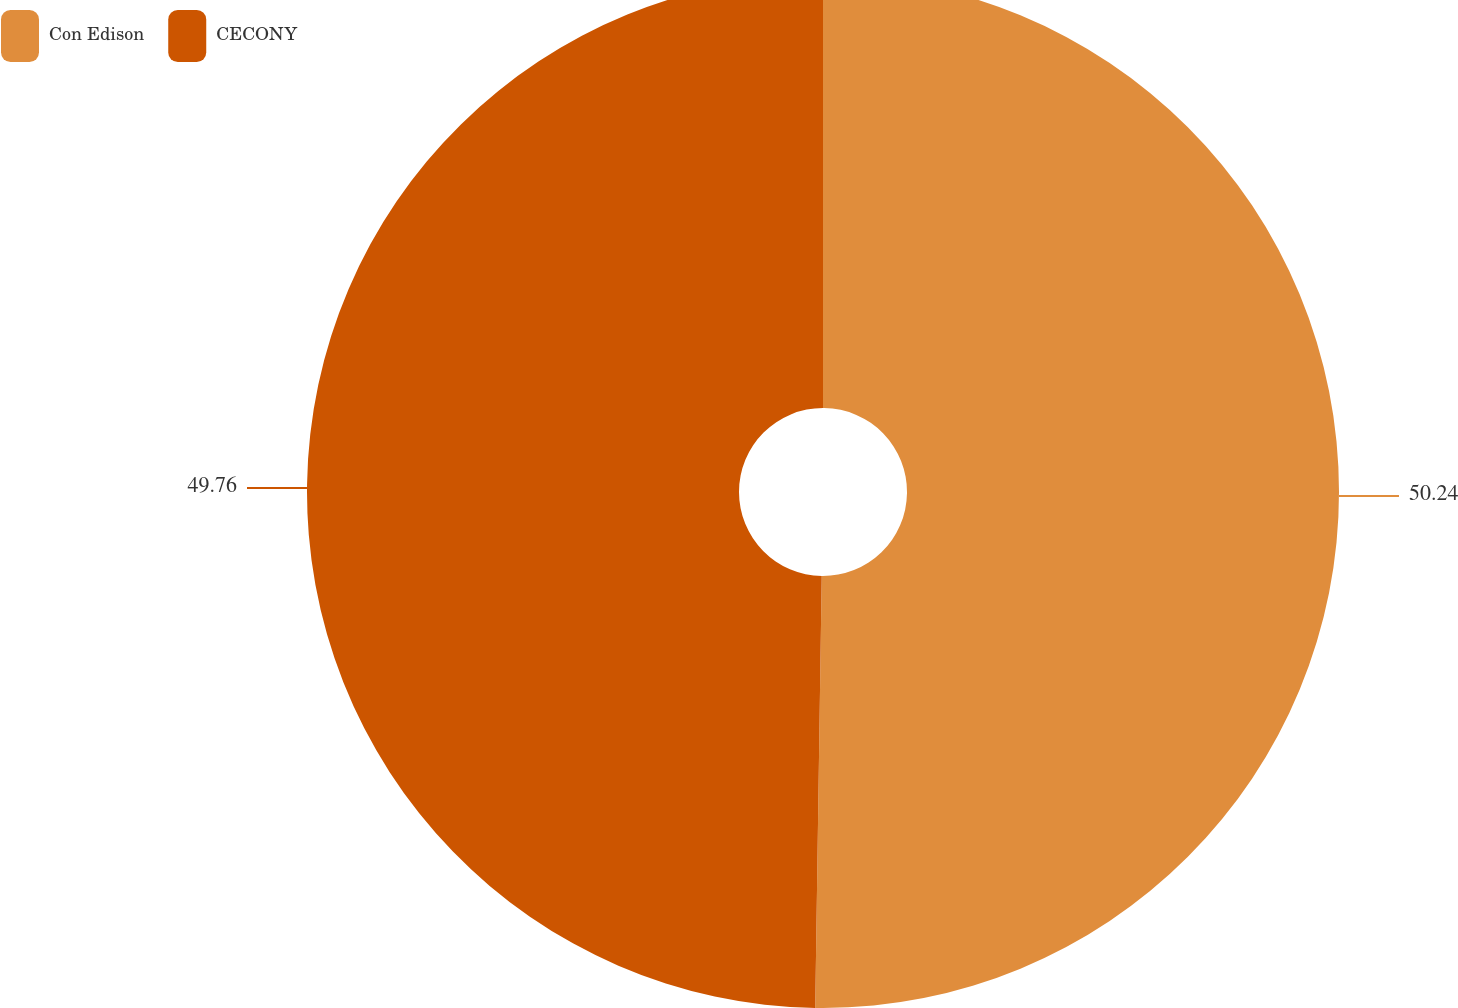Convert chart. <chart><loc_0><loc_0><loc_500><loc_500><pie_chart><fcel>Con Edison<fcel>CECONY<nl><fcel>50.24%<fcel>49.76%<nl></chart> 